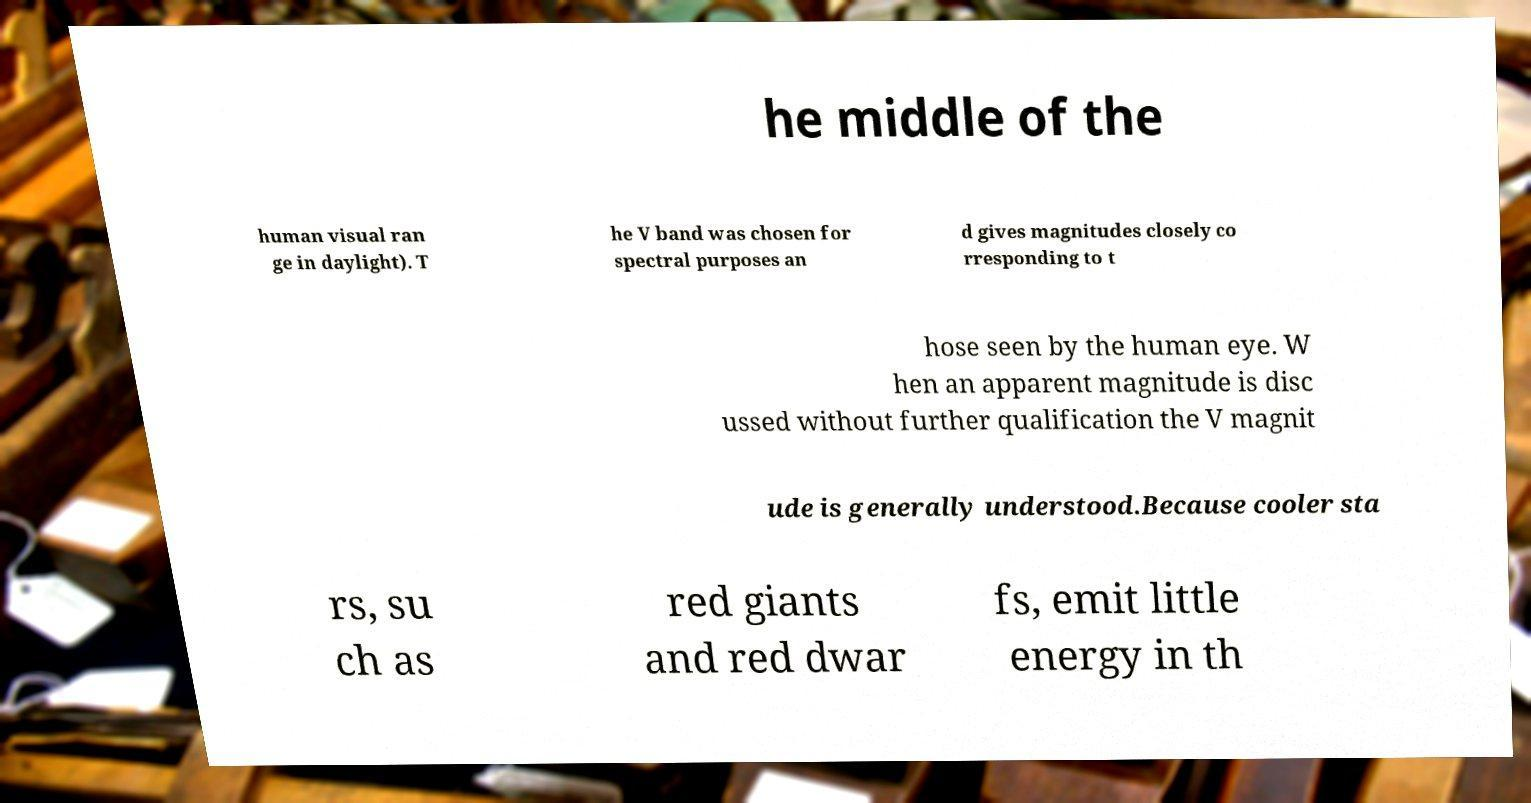What messages or text are displayed in this image? I need them in a readable, typed format. he middle of the human visual ran ge in daylight). T he V band was chosen for spectral purposes an d gives magnitudes closely co rresponding to t hose seen by the human eye. W hen an apparent magnitude is disc ussed without further qualification the V magnit ude is generally understood.Because cooler sta rs, su ch as red giants and red dwar fs, emit little energy in th 